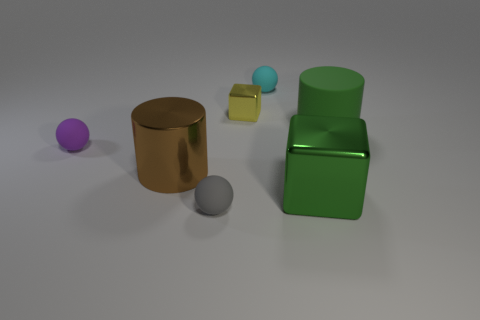What color is the big object that is to the left of the green thing on the left side of the large matte cylinder?
Offer a terse response. Brown. There is a cylinder that is behind the large brown metallic cylinder; what material is it?
Your answer should be compact. Rubber. Is the number of metallic cylinders less than the number of small yellow rubber cubes?
Offer a terse response. No. There is a tiny purple object; is its shape the same as the thing that is in front of the large green metal block?
Offer a terse response. Yes. What is the shape of the metallic object that is both on the right side of the small gray matte thing and in front of the small metal thing?
Provide a succinct answer. Cube. Is the number of tiny yellow metallic blocks that are right of the yellow cube the same as the number of large brown cylinders that are behind the small cyan matte sphere?
Ensure brevity in your answer.  Yes. There is a metal thing that is in front of the large brown cylinder; is its shape the same as the tiny metal thing?
Your answer should be compact. Yes. How many yellow objects are large matte cylinders or shiny cubes?
Give a very brief answer. 1. What is the material of the tiny purple object that is the same shape as the cyan rubber object?
Your answer should be very brief. Rubber. There is a big object that is behind the big brown metal cylinder; what is its shape?
Provide a short and direct response. Cylinder. 